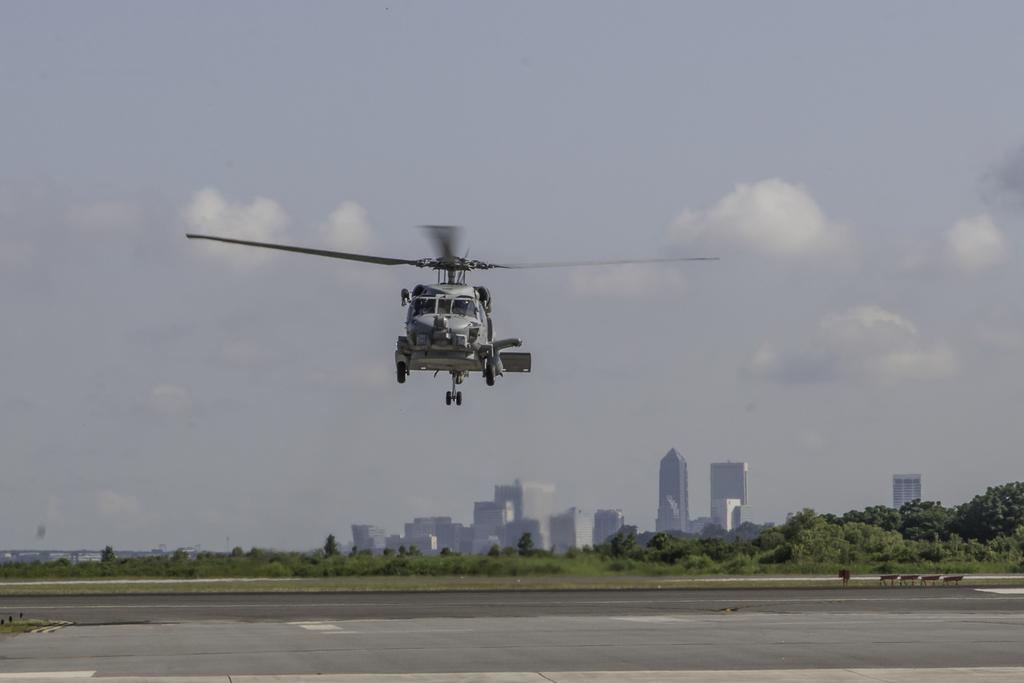What is flying in the air in the image? There is a helicopter flying in the air in the image. What can be seen on the ground in the image? There is a road visible in the image. What type of vegetation is present in the image? Plants and trees are visible in the image. What type of structures are present in the image? Buildings are present in the image. What else can be seen in the image besides the helicopter and structures? There are objects in the image. What is visible in the background of the image? The sky is visible in the background of the image. What can be seen in the sky? Clouds are present in the sky. What type of art can be seen on the helicopter in the image? There is no art visible on the helicopter in the image. What type of soda is being served in the image? There is no soda present in the image. What type of button is being used by the helicopter pilot in the image? There is no button visible in the image, and we cannot determine the actions of the helicopter pilot. 